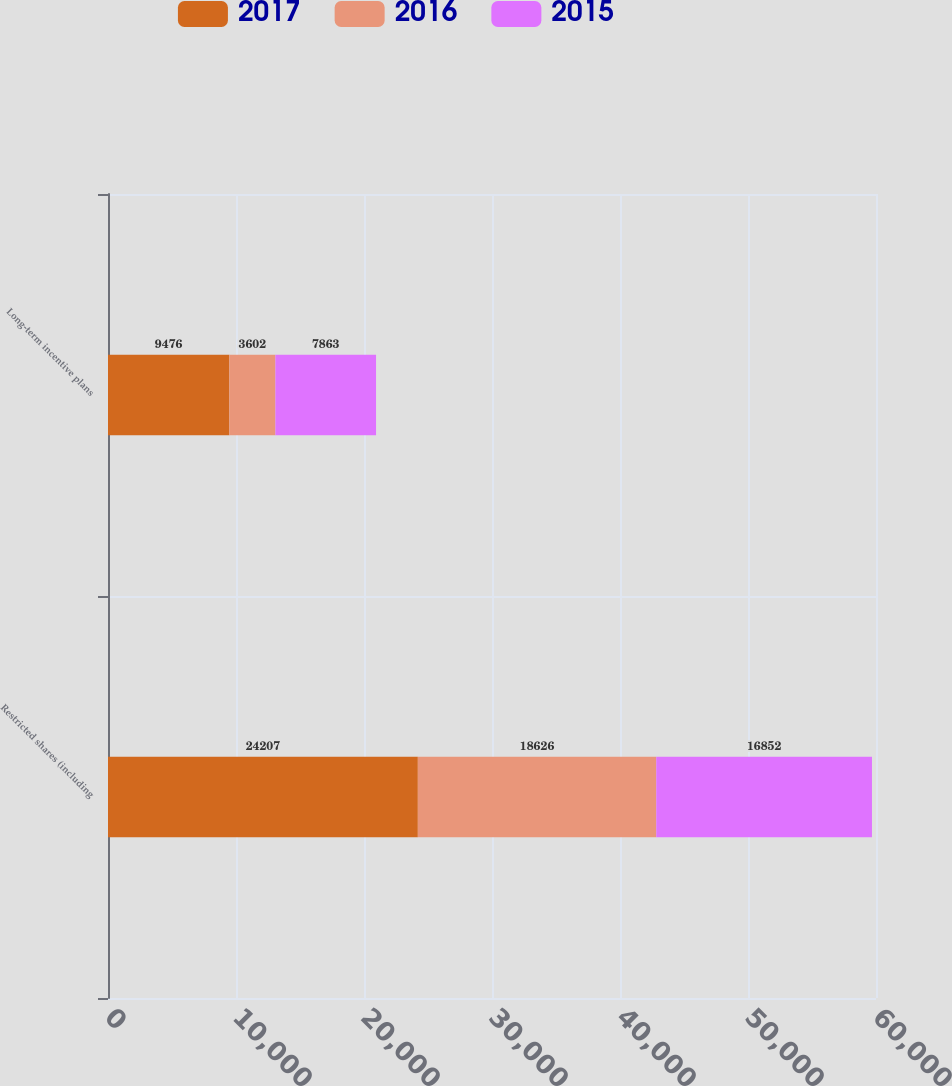<chart> <loc_0><loc_0><loc_500><loc_500><stacked_bar_chart><ecel><fcel>Restricted shares (including<fcel>Long-term incentive plans<nl><fcel>2017<fcel>24207<fcel>9476<nl><fcel>2016<fcel>18626<fcel>3602<nl><fcel>2015<fcel>16852<fcel>7863<nl></chart> 